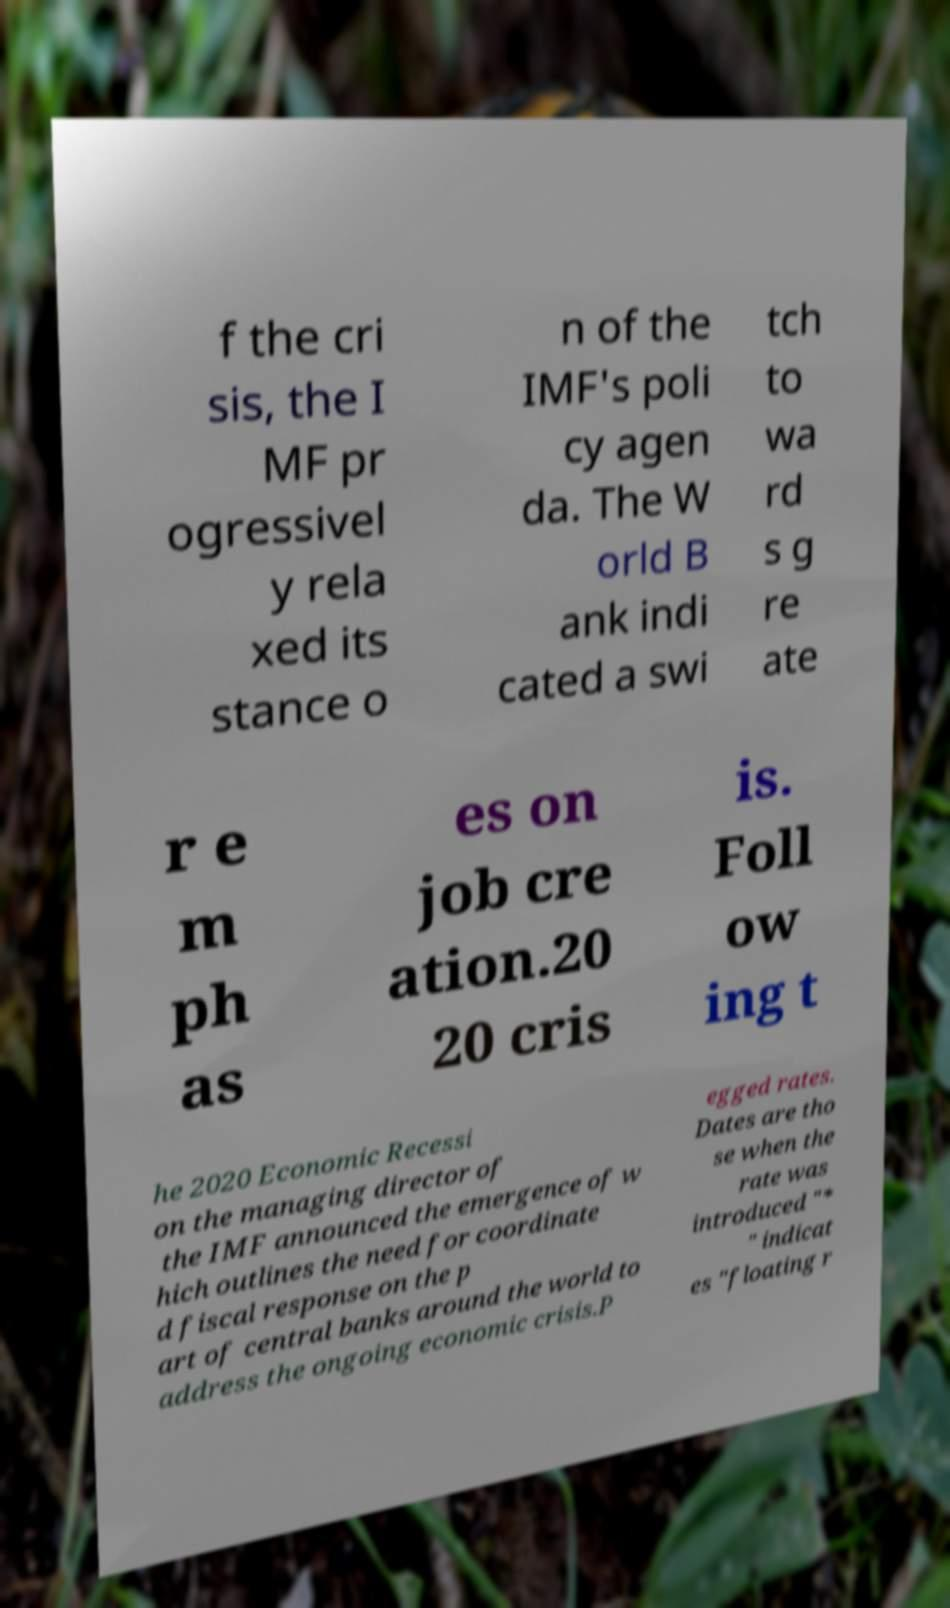For documentation purposes, I need the text within this image transcribed. Could you provide that? f the cri sis, the I MF pr ogressivel y rela xed its stance o n of the IMF's poli cy agen da. The W orld B ank indi cated a swi tch to wa rd s g re ate r e m ph as es on job cre ation.20 20 cris is. Foll ow ing t he 2020 Economic Recessi on the managing director of the IMF announced the emergence of w hich outlines the need for coordinate d fiscal response on the p art of central banks around the world to address the ongoing economic crisis.P egged rates. Dates are tho se when the rate was introduced "* " indicat es "floating r 